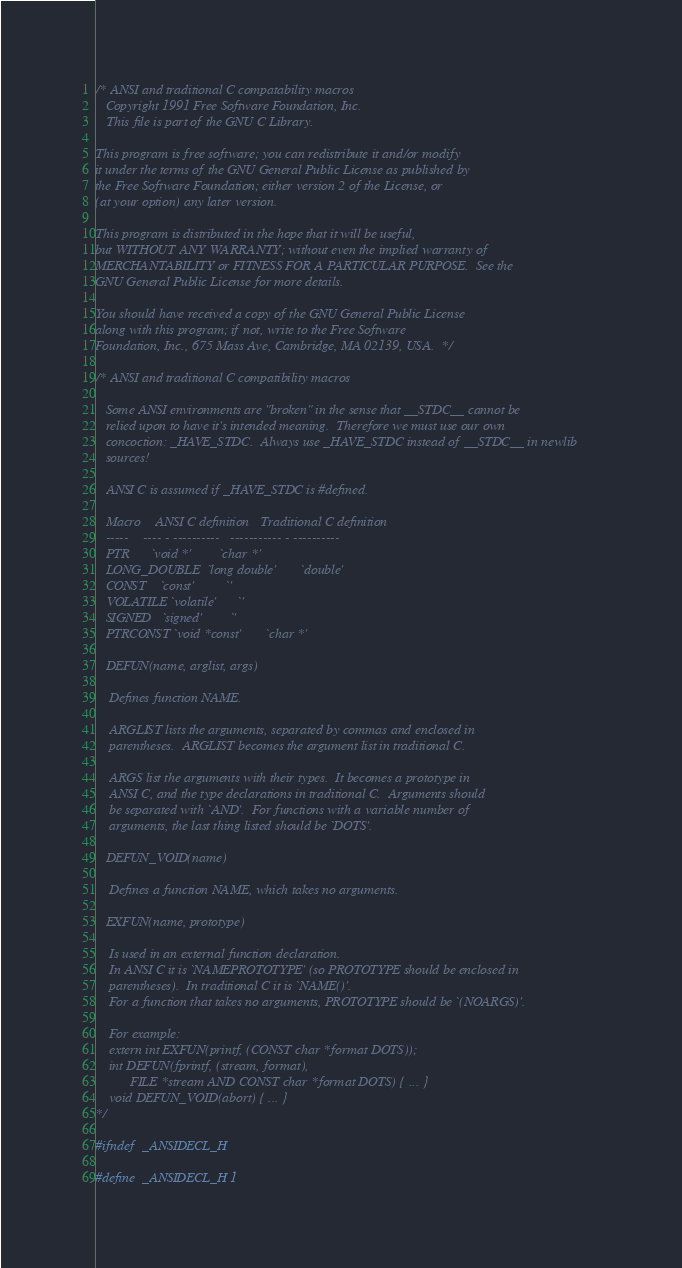<code> <loc_0><loc_0><loc_500><loc_500><_C_>/* ANSI and traditional C compatability macros
   Copyright 1991 Free Software Foundation, Inc.
   This file is part of the GNU C Library.

This program is free software; you can redistribute it and/or modify
it under the terms of the GNU General Public License as published by
the Free Software Foundation; either version 2 of the License, or
(at your option) any later version.

This program is distributed in the hope that it will be useful,
but WITHOUT ANY WARRANTY; without even the implied warranty of
MERCHANTABILITY or FITNESS FOR A PARTICULAR PURPOSE.  See the
GNU General Public License for more details.

You should have received a copy of the GNU General Public License
along with this program; if not, write to the Free Software
Foundation, Inc., 675 Mass Ave, Cambridge, MA 02139, USA.  */

/* ANSI and traditional C compatibility macros

   Some ANSI environments are "broken" in the sense that __STDC__ cannot be
   relied upon to have it's intended meaning.  Therefore we must use our own
   concoction: _HAVE_STDC.  Always use _HAVE_STDC instead of __STDC__ in newlib
   sources!

   ANSI C is assumed if _HAVE_STDC is #defined.

   Macro	ANSI C definition	Traditional C definition
   -----	---- - ----------	----------- - ----------
   PTR		`void *'		`char *'
   LONG_DOUBLE	`long double'		`double'
   CONST	`const'			`'
   VOLATILE	`volatile'		`'
   SIGNED	`signed'		`'
   PTRCONST	`void *const'		`char *'

   DEFUN(name, arglist, args)

	Defines function NAME.

	ARGLIST lists the arguments, separated by commas and enclosed in
	parentheses.  ARGLIST becomes the argument list in traditional C.

	ARGS list the arguments with their types.  It becomes a prototype in
	ANSI C, and the type declarations in traditional C.  Arguments should
	be separated with `AND'.  For functions with a variable number of
	arguments, the last thing listed should be `DOTS'.

   DEFUN_VOID(name)

	Defines a function NAME, which takes no arguments.

   EXFUN(name, prototype)

	Is used in an external function declaration.
	In ANSI C it is `NAMEPROTOTYPE' (so PROTOTYPE should be enclosed in
	parentheses).  In traditional C it is `NAME()'.
	For a function that takes no arguments, PROTOTYPE should be `(NOARGS)'.

    For example:
	extern int EXFUN(printf, (CONST char *format DOTS));
	int DEFUN(fprintf, (stream, format),
		  FILE *stream AND CONST char *format DOTS) { ... }
	void DEFUN_VOID(abort) { ... }
*/

#ifndef	_ANSIDECL_H

#define	_ANSIDECL_H	1

</code> 